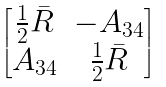Convert formula to latex. <formula><loc_0><loc_0><loc_500><loc_500>\begin{bmatrix} \frac { 1 } { 2 } \bar { R } & - A _ { 3 4 } \\ A _ { 3 4 } & \frac { 1 } { 2 } \bar { R } \end{bmatrix}</formula> 